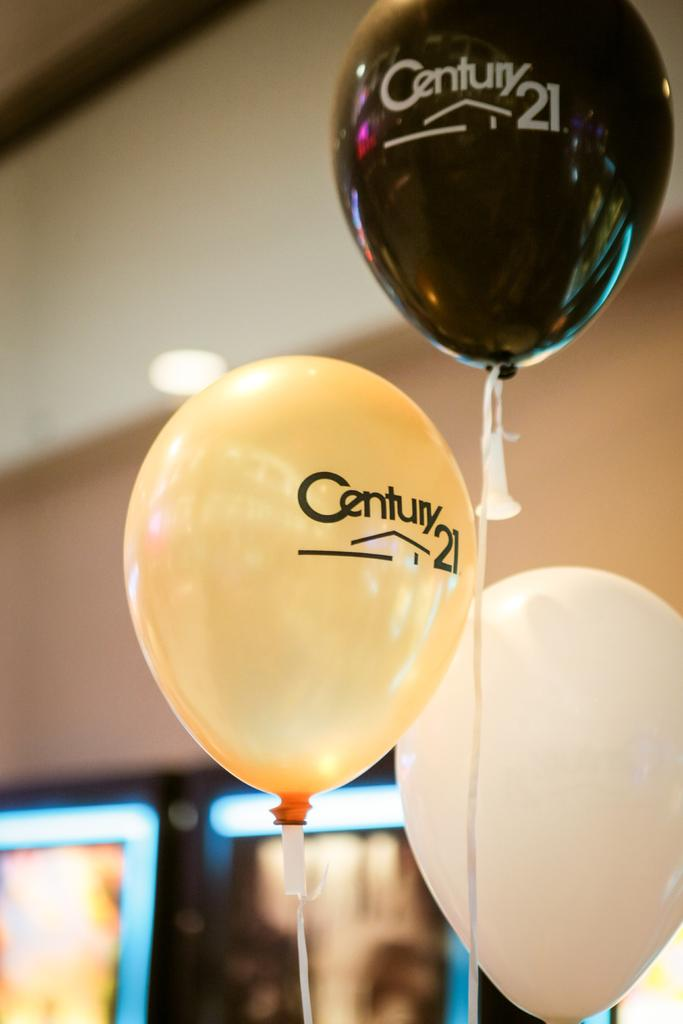How many balloons are visible in the image? There are three balloons in the image. What is written on the balloons? There is writing on the balloons. What can be seen in the background of the image? There is a wall in the background of the image. How would you describe the appearance of the wall? The wall appears blurred. What type of screw is holding the balloons to the coast in the image? There is no coast or screw present in the image; it features three balloons with writing and a blurred wall in the background. 